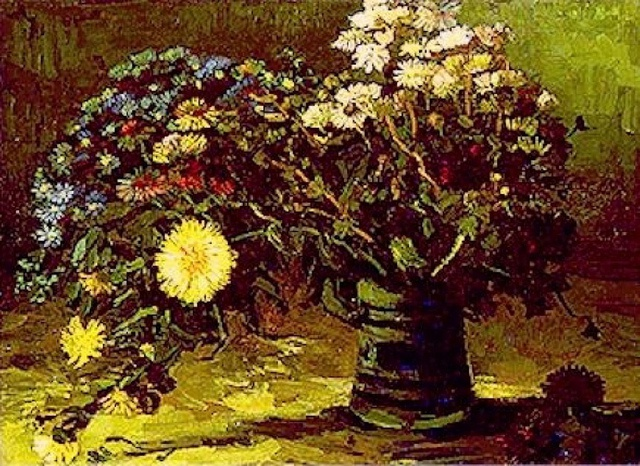Describe the objects in this image and their specific colors. I can see potted plant in maroon, black, olive, and tan tones and vase in maroon, black, olive, and gray tones in this image. 